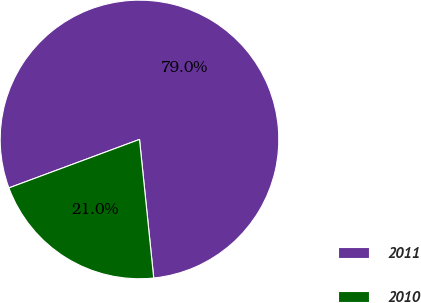Convert chart. <chart><loc_0><loc_0><loc_500><loc_500><pie_chart><fcel>2011<fcel>2010<nl><fcel>79.03%<fcel>20.97%<nl></chart> 